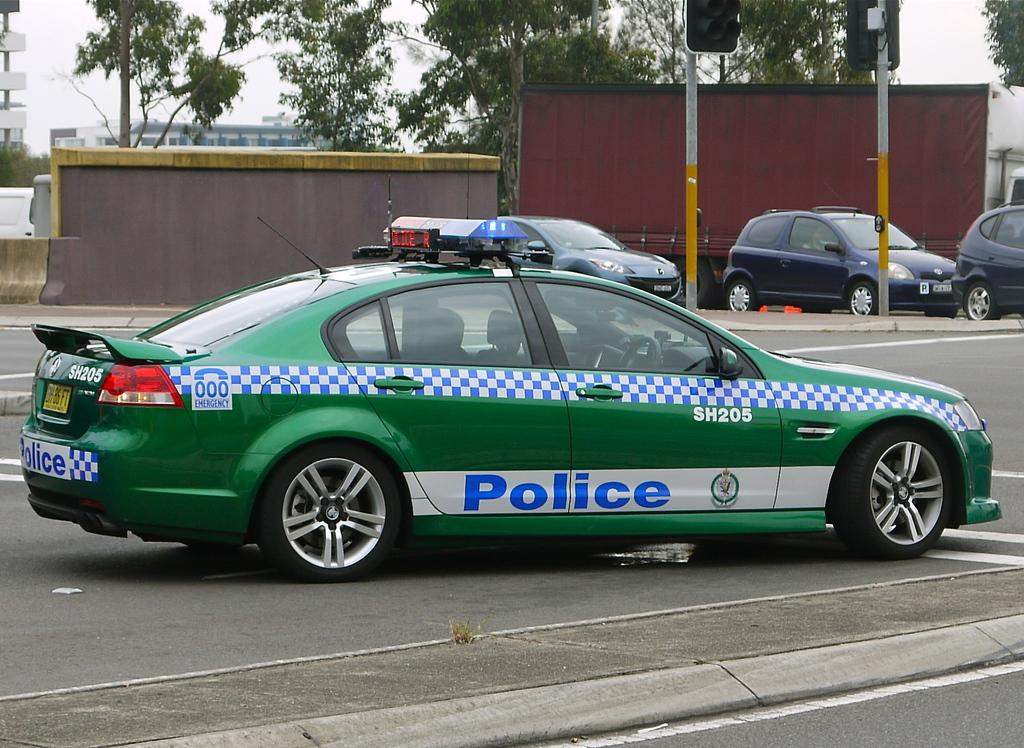<image>
Write a terse but informative summary of the picture. A green car that says Police is nearing an intersection. 